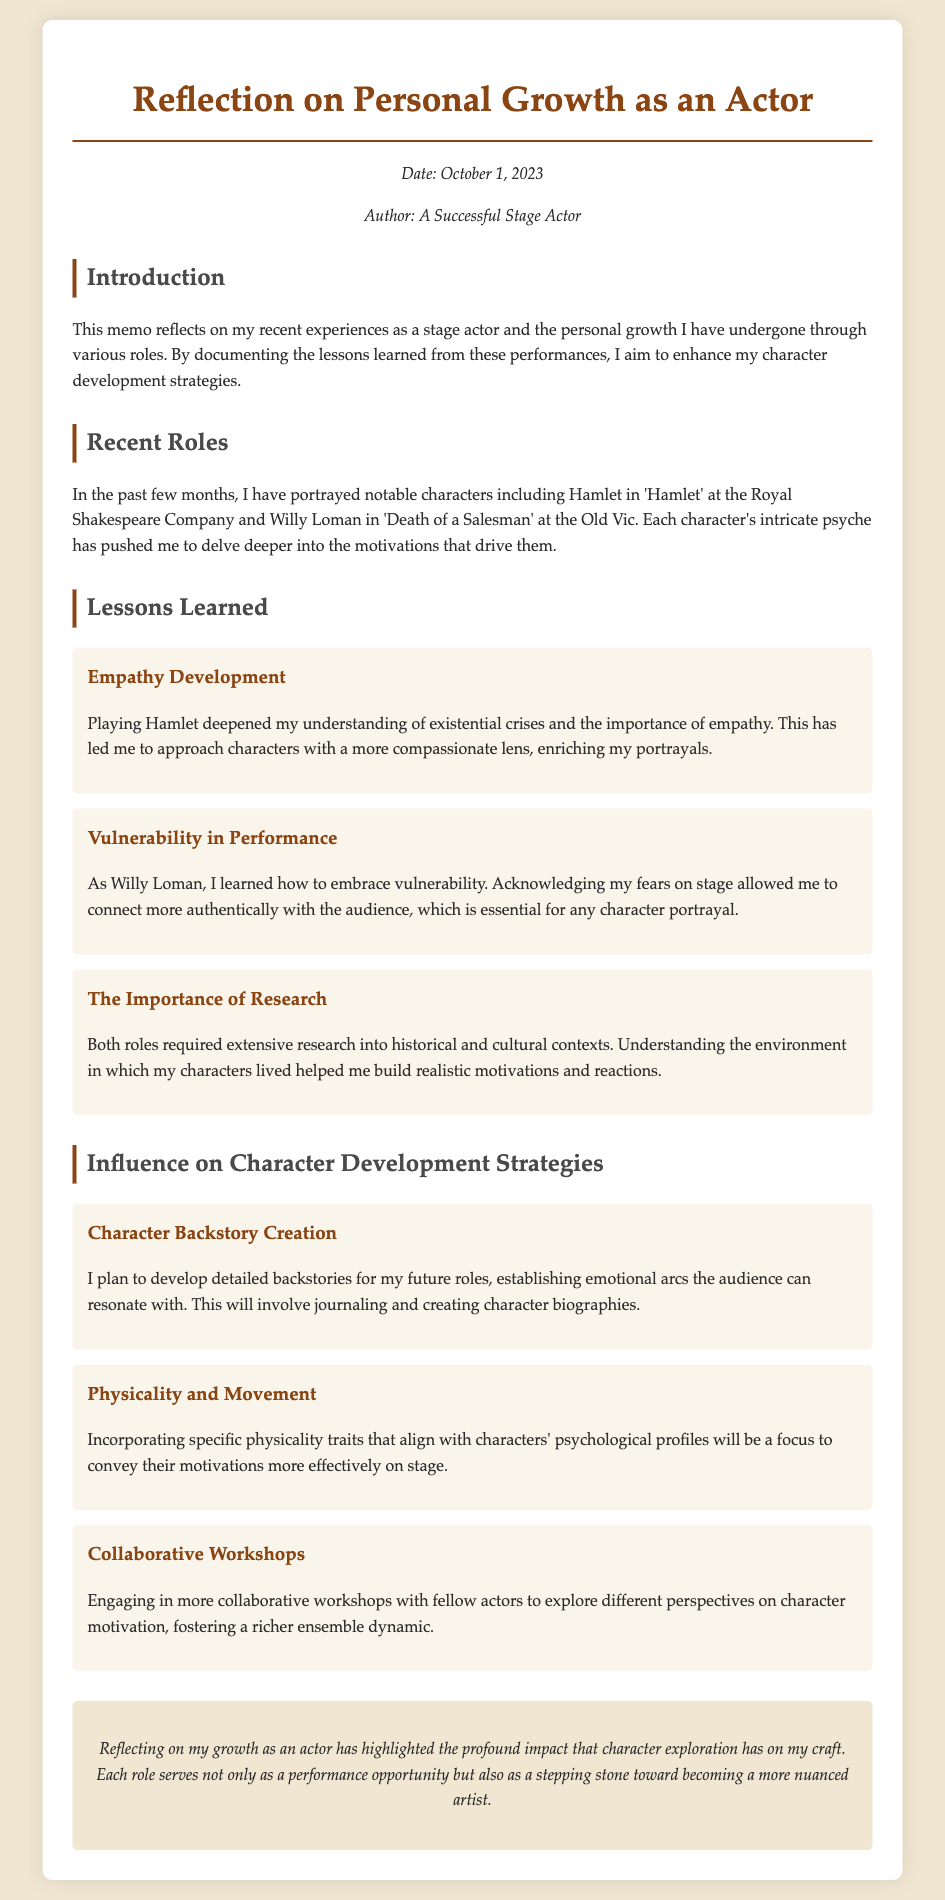What roles did the author portray recently? The document lists the characters the author portrayed as Hamlet in 'Hamlet' and Willy Loman in 'Death of a Salesman'.
Answer: Hamlet, Willy Loman What is the date of this memo? The memo includes a specific date of reflection, which is stated at the beginning.
Answer: October 1, 2023 What lesson did playing Hamlet teach the author? The author reflects on a specific lesson learned from playing Hamlet related to empathy and understanding.
Answer: Empathy Development What strategy involves creating character biographies? The document details a character development strategy that includes journaling and backstory creation.
Answer: Character Backstory Creation How has vulnerability influenced the author's performance? The memo discusses how embracing vulnerability affected the author's connection with the audience while playing Willy Loman.
Answer: Connect more authentically What method does the author plan to use to convey character motivations? The author outlines a strategy focused on specific physical traits to better represent character psychology.
Answer: Physicality and Movement What is a key aspect of the author's character development strategy? A significant focus for the author’s future roles involves collaborative work with fellow actors to enhance character understanding.
Answer: Collaborative Workshops How does the author describe their growth as an actor? The concluding remarks summarize the author’s reflection on their overall development through character exploration.
Answer: Profound impact What was a requirement for both roles played by the author? The document emphasizes a critical need for research related to historical and cultural contexts for those roles.
Answer: Extensive research 